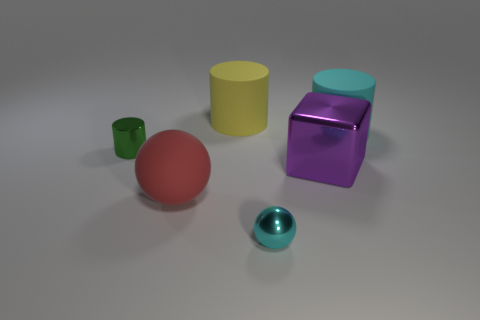Add 3 big red matte balls. How many objects exist? 9 Subtract all balls. How many objects are left? 4 Subtract all blue rubber balls. Subtract all big purple metal blocks. How many objects are left? 5 Add 2 yellow rubber cylinders. How many yellow rubber cylinders are left? 3 Add 6 tiny yellow metal blocks. How many tiny yellow metal blocks exist? 6 Subtract 0 brown spheres. How many objects are left? 6 